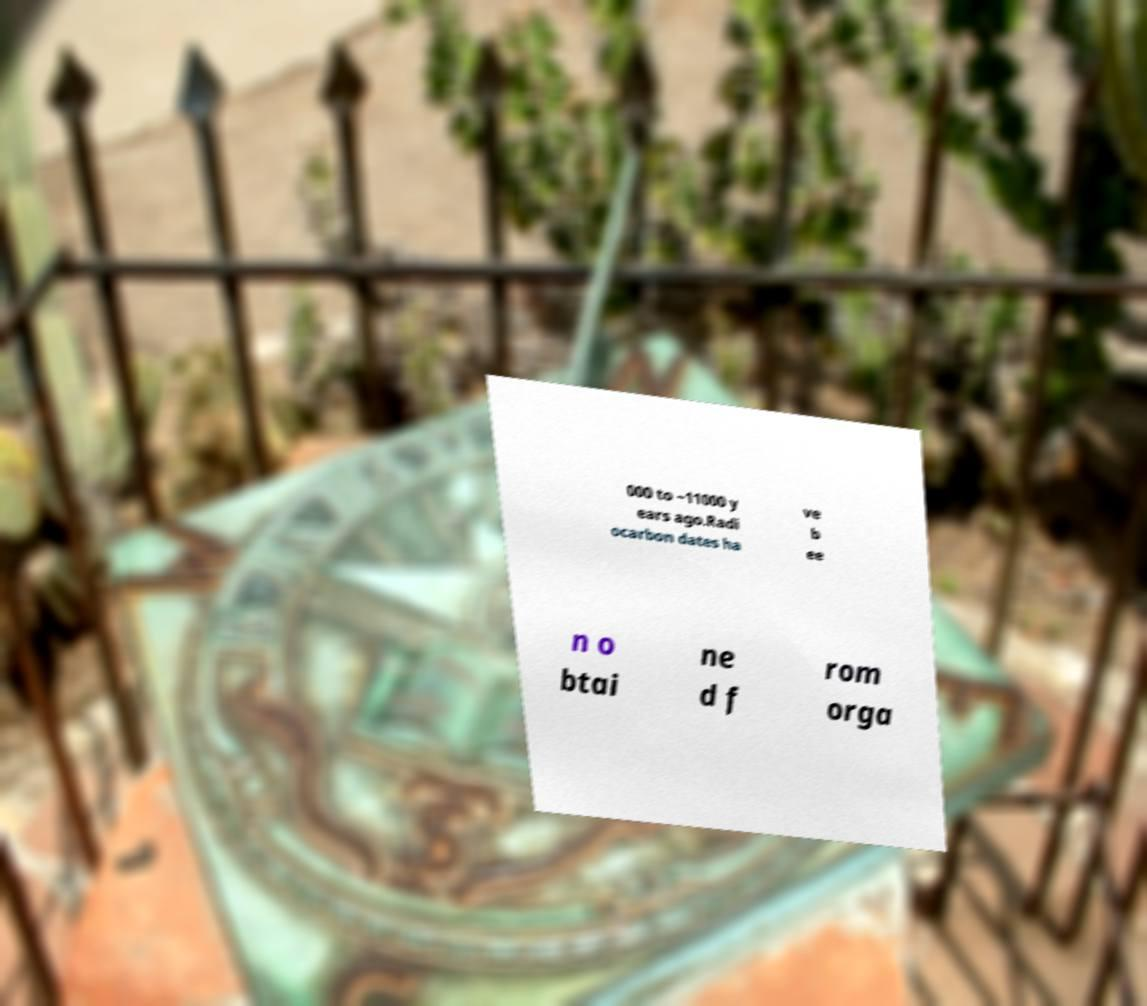Could you assist in decoding the text presented in this image and type it out clearly? 000 to ~11000 y ears ago.Radi ocarbon dates ha ve b ee n o btai ne d f rom orga 